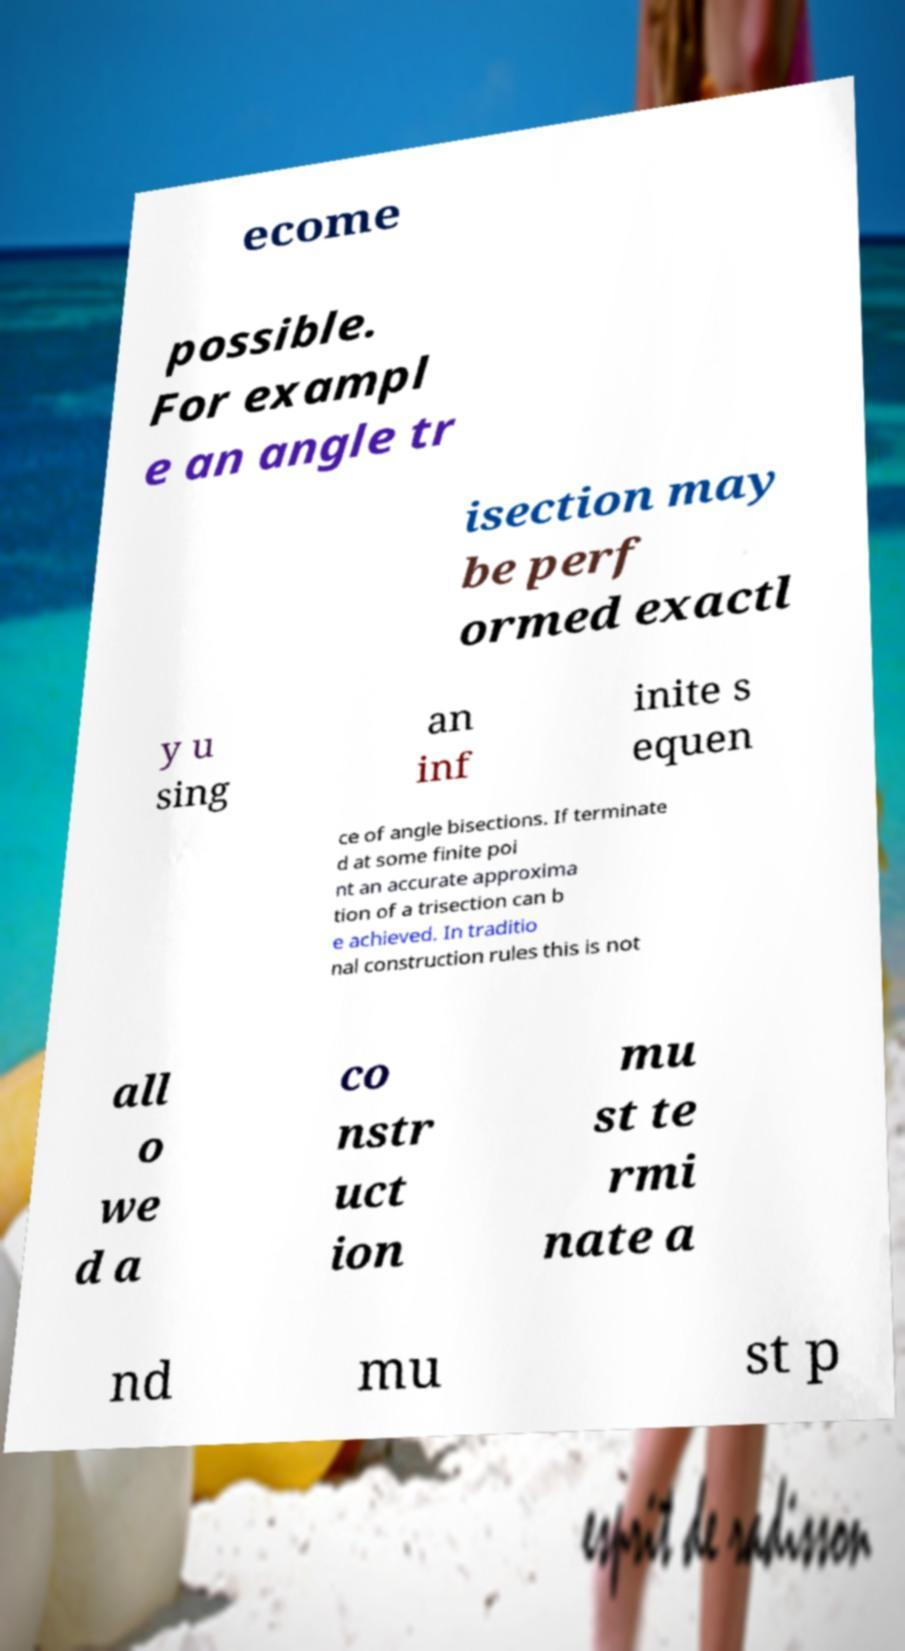Could you extract and type out the text from this image? ecome possible. For exampl e an angle tr isection may be perf ormed exactl y u sing an inf inite s equen ce of angle bisections. If terminate d at some finite poi nt an accurate approxima tion of a trisection can b e achieved. In traditio nal construction rules this is not all o we d a co nstr uct ion mu st te rmi nate a nd mu st p 